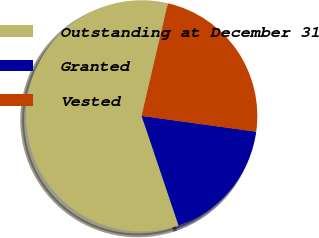Convert chart to OTSL. <chart><loc_0><loc_0><loc_500><loc_500><pie_chart><fcel>Outstanding at December 31<fcel>Granted<fcel>Vested<nl><fcel>58.82%<fcel>17.65%<fcel>23.53%<nl></chart> 